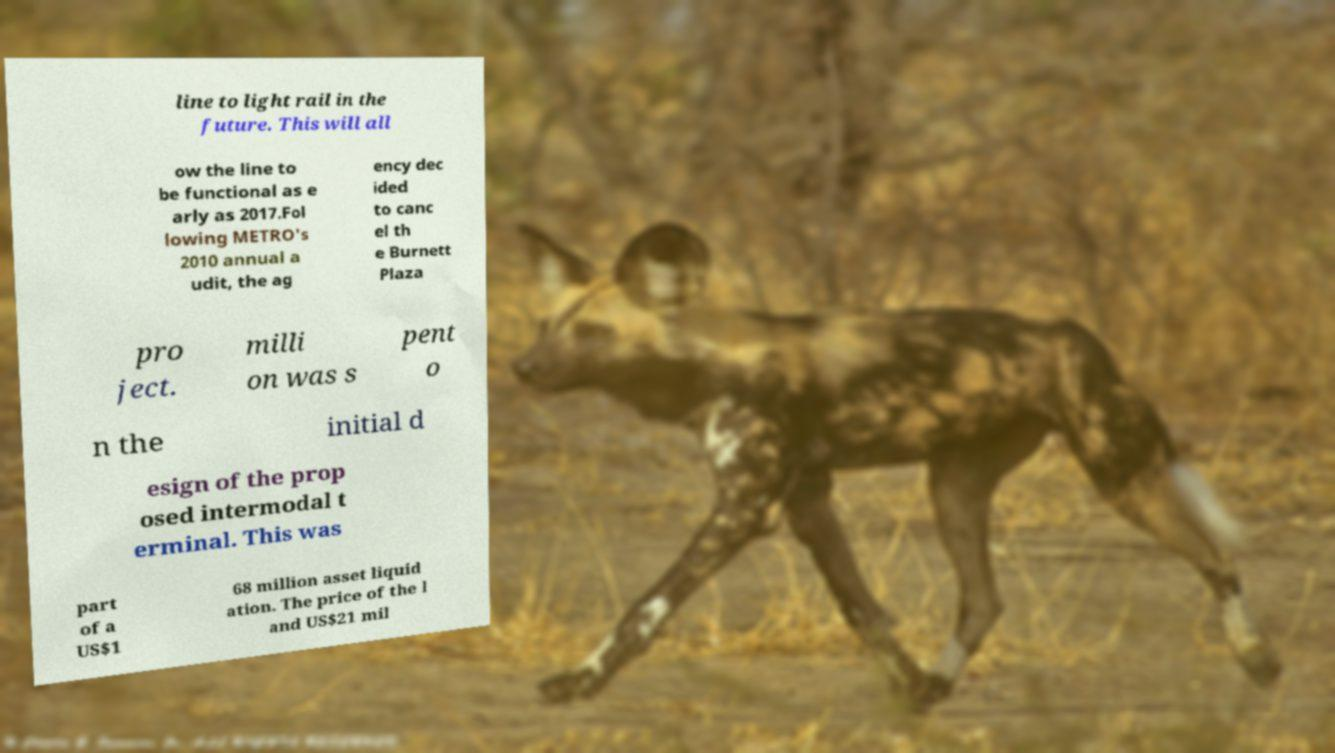There's text embedded in this image that I need extracted. Can you transcribe it verbatim? line to light rail in the future. This will all ow the line to be functional as e arly as 2017.Fol lowing METRO's 2010 annual a udit, the ag ency dec ided to canc el th e Burnett Plaza pro ject. milli on was s pent o n the initial d esign of the prop osed intermodal t erminal. This was part of a US$1 68 million asset liquid ation. The price of the l and US$21 mil 